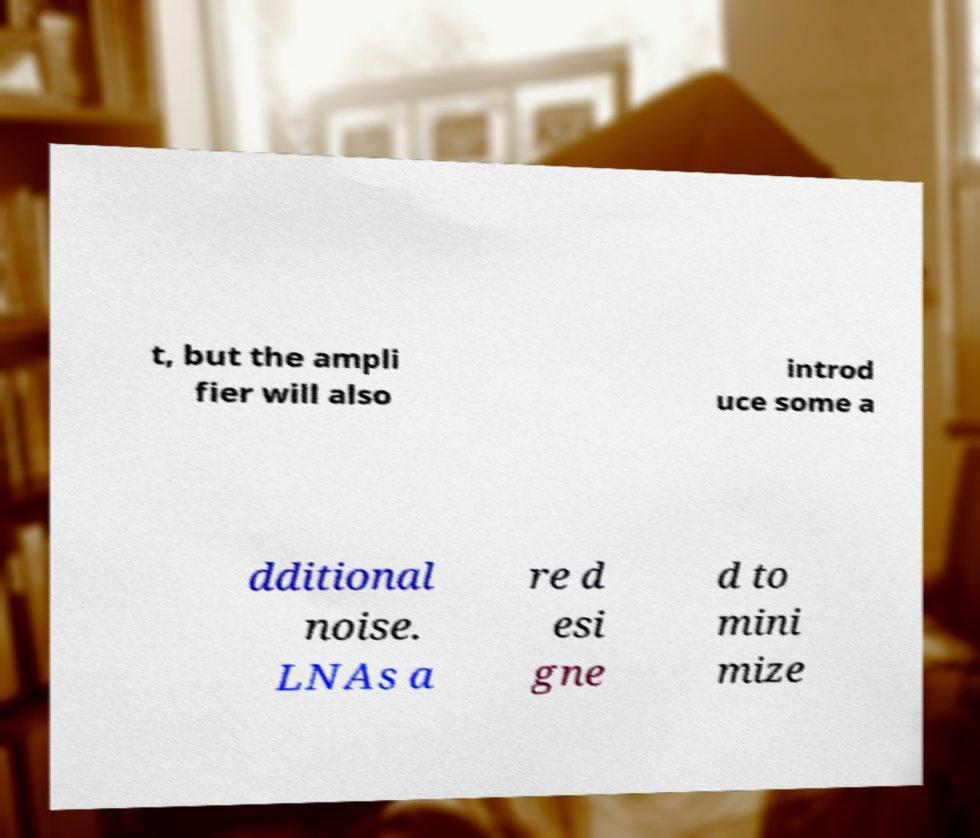Could you extract and type out the text from this image? t, but the ampli fier will also introd uce some a dditional noise. LNAs a re d esi gne d to mini mize 